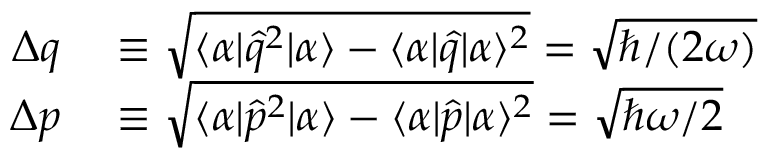Convert formula to latex. <formula><loc_0><loc_0><loc_500><loc_500>\begin{array} { r l } { \Delta q } & \equiv \sqrt { \langle \alpha | \hat { q } ^ { 2 } | \alpha \rangle - \langle \alpha | \hat { q } | \alpha \rangle ^ { 2 } } = \sqrt { \hbar { / } ( 2 \omega ) } } \\ { \Delta p } & \equiv \sqrt { \langle \alpha | \hat { p } ^ { 2 } | \alpha \rangle - \langle \alpha | \hat { p } | \alpha \rangle ^ { 2 } } = \sqrt { \hbar { \omega } / 2 } } \end{array}</formula> 